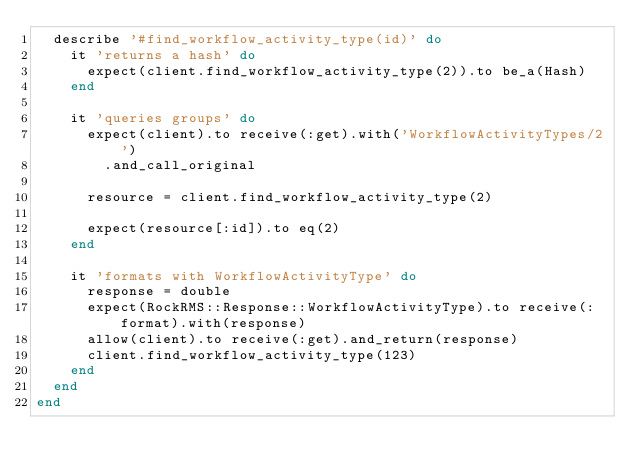<code> <loc_0><loc_0><loc_500><loc_500><_Ruby_>  describe '#find_workflow_activity_type(id)' do
    it 'returns a hash' do
      expect(client.find_workflow_activity_type(2)).to be_a(Hash)
    end

    it 'queries groups' do
      expect(client).to receive(:get).with('WorkflowActivityTypes/2')
        .and_call_original

      resource = client.find_workflow_activity_type(2)

      expect(resource[:id]).to eq(2)
    end

    it 'formats with WorkflowActivityType' do
      response = double
      expect(RockRMS::Response::WorkflowActivityType).to receive(:format).with(response)
      allow(client).to receive(:get).and_return(response)
      client.find_workflow_activity_type(123)
    end
  end
end


</code> 